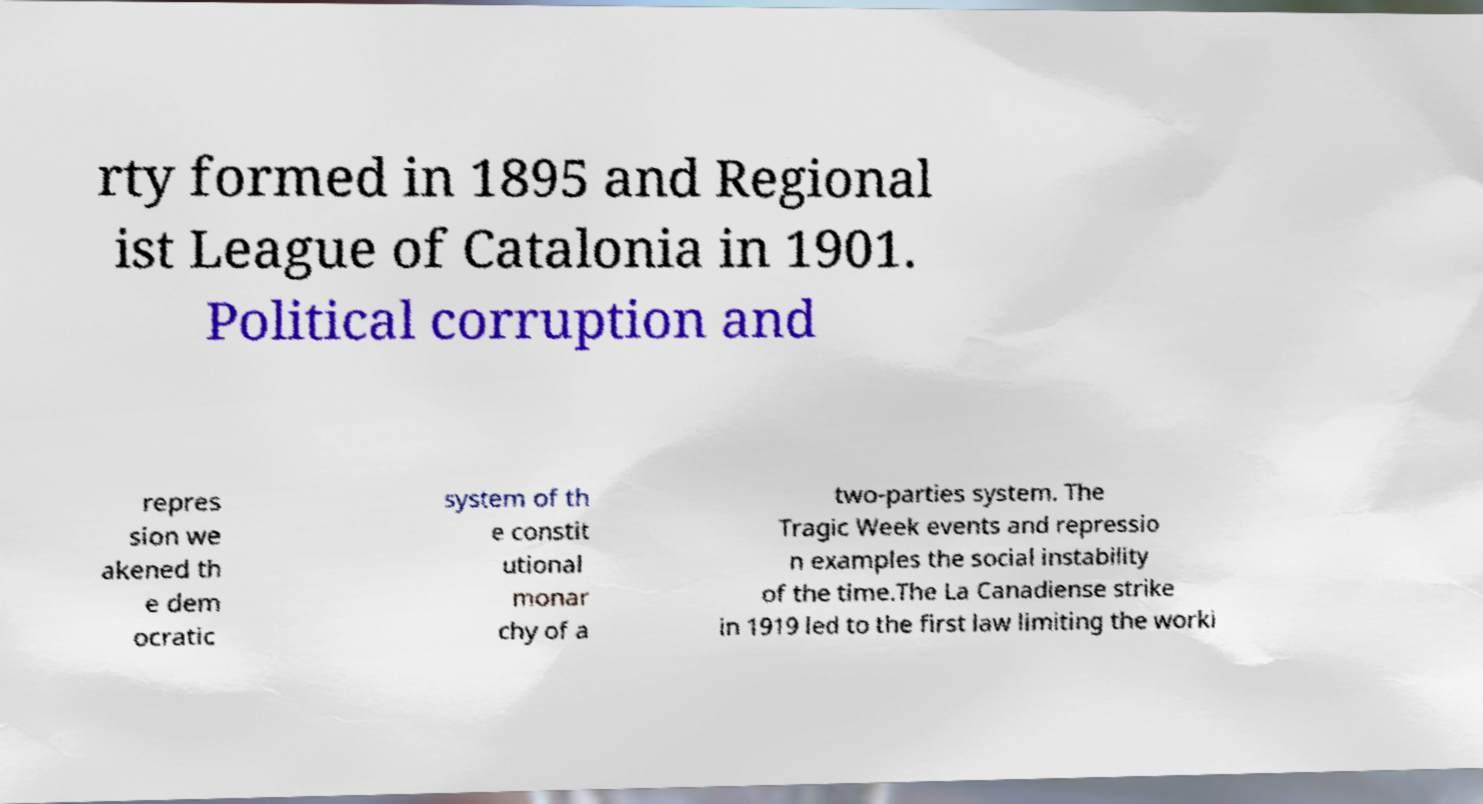Can you read and provide the text displayed in the image?This photo seems to have some interesting text. Can you extract and type it out for me? rty formed in 1895 and Regional ist League of Catalonia in 1901. Political corruption and repres sion we akened th e dem ocratic system of th e constit utional monar chy of a two-parties system. The Tragic Week events and repressio n examples the social instability of the time.The La Canadiense strike in 1919 led to the first law limiting the worki 